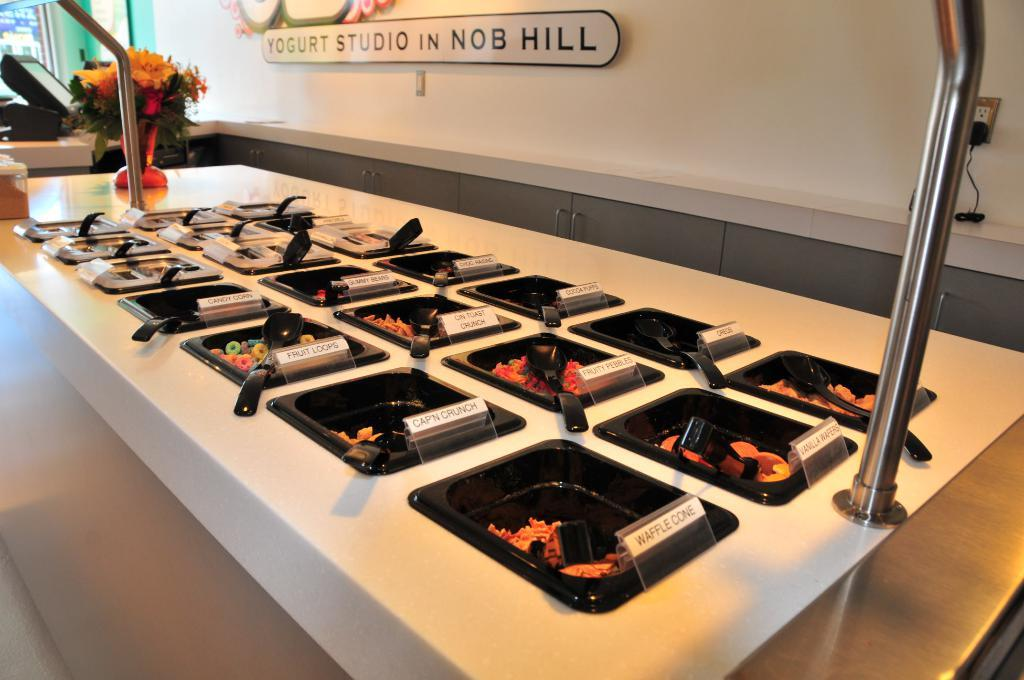<image>
Relay a brief, clear account of the picture shown. A snack bar at a yogurt studio in Nob Hill. 